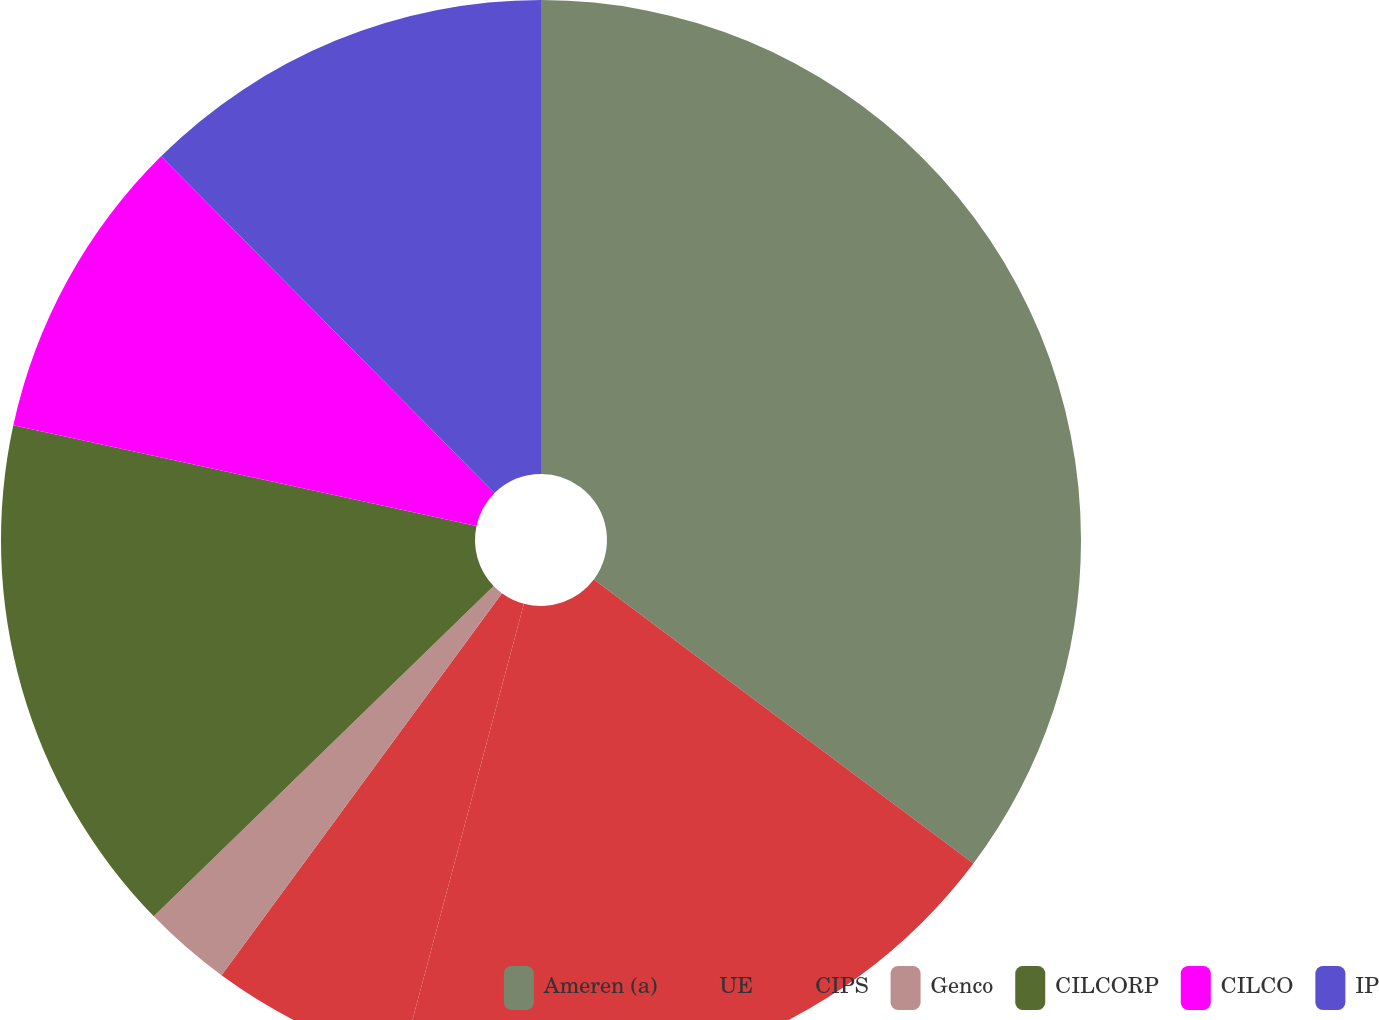<chart> <loc_0><loc_0><loc_500><loc_500><pie_chart><fcel>Ameren (a)<fcel>UE<fcel>CIPS<fcel>Genco<fcel>CILCORP<fcel>CILCO<fcel>IP<nl><fcel>35.22%<fcel>18.94%<fcel>5.91%<fcel>2.65%<fcel>15.68%<fcel>9.17%<fcel>12.42%<nl></chart> 